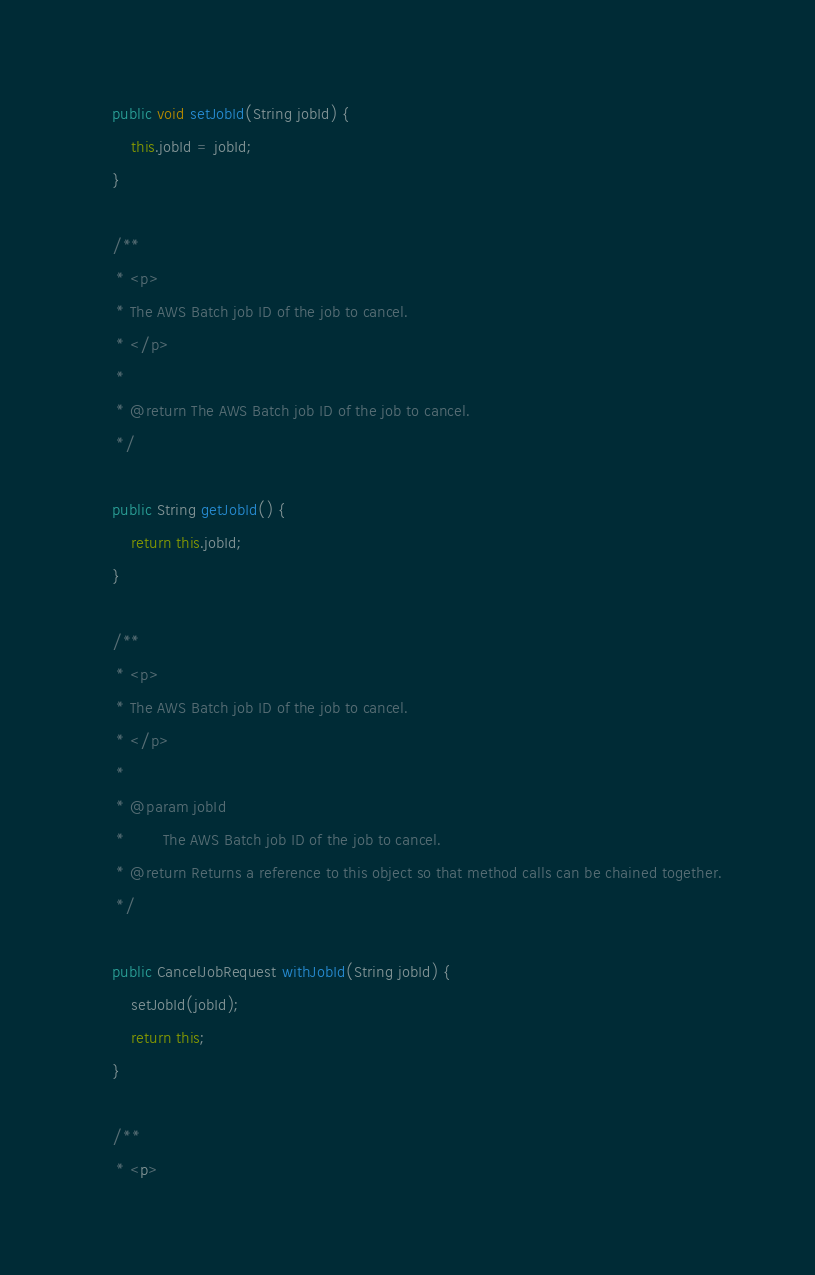<code> <loc_0><loc_0><loc_500><loc_500><_Java_>
    public void setJobId(String jobId) {
        this.jobId = jobId;
    }

    /**
     * <p>
     * The AWS Batch job ID of the job to cancel.
     * </p>
     * 
     * @return The AWS Batch job ID of the job to cancel.
     */

    public String getJobId() {
        return this.jobId;
    }

    /**
     * <p>
     * The AWS Batch job ID of the job to cancel.
     * </p>
     * 
     * @param jobId
     *        The AWS Batch job ID of the job to cancel.
     * @return Returns a reference to this object so that method calls can be chained together.
     */

    public CancelJobRequest withJobId(String jobId) {
        setJobId(jobId);
        return this;
    }

    /**
     * <p></code> 